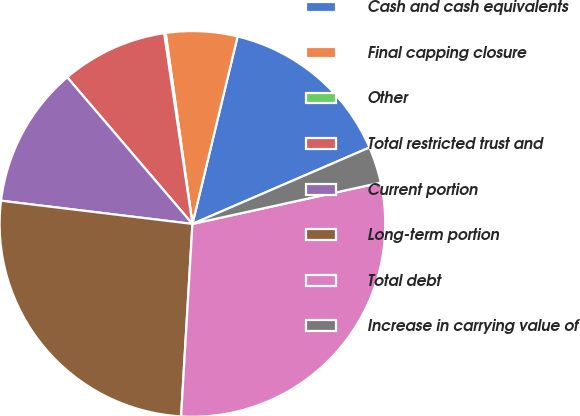Convert chart. <chart><loc_0><loc_0><loc_500><loc_500><pie_chart><fcel>Cash and cash equivalents<fcel>Final capping closure<fcel>Other<fcel>Total restricted trust and<fcel>Current portion<fcel>Long-term portion<fcel>Total debt<fcel>Increase in carrying value of<nl><fcel>14.75%<fcel>5.98%<fcel>0.13%<fcel>8.9%<fcel>11.83%<fcel>25.98%<fcel>29.37%<fcel>3.05%<nl></chart> 